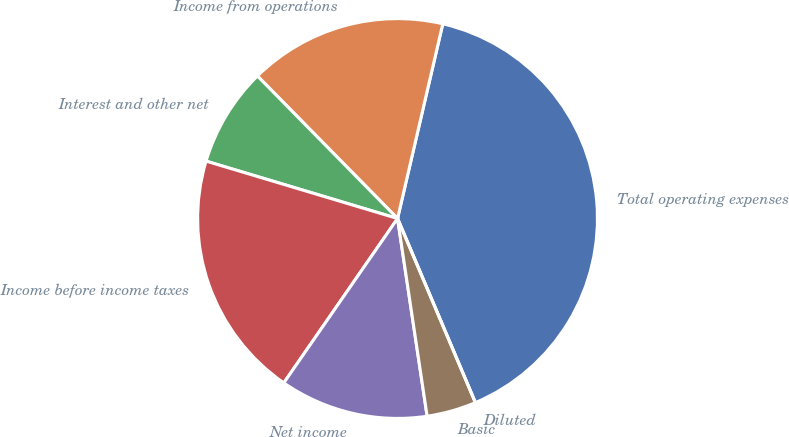Convert chart. <chart><loc_0><loc_0><loc_500><loc_500><pie_chart><fcel>Total operating expenses<fcel>Income from operations<fcel>Interest and other net<fcel>Income before income taxes<fcel>Net income<fcel>Basic<fcel>Diluted<nl><fcel>40.0%<fcel>16.0%<fcel>8.0%<fcel>20.0%<fcel>12.0%<fcel>4.0%<fcel>0.0%<nl></chart> 